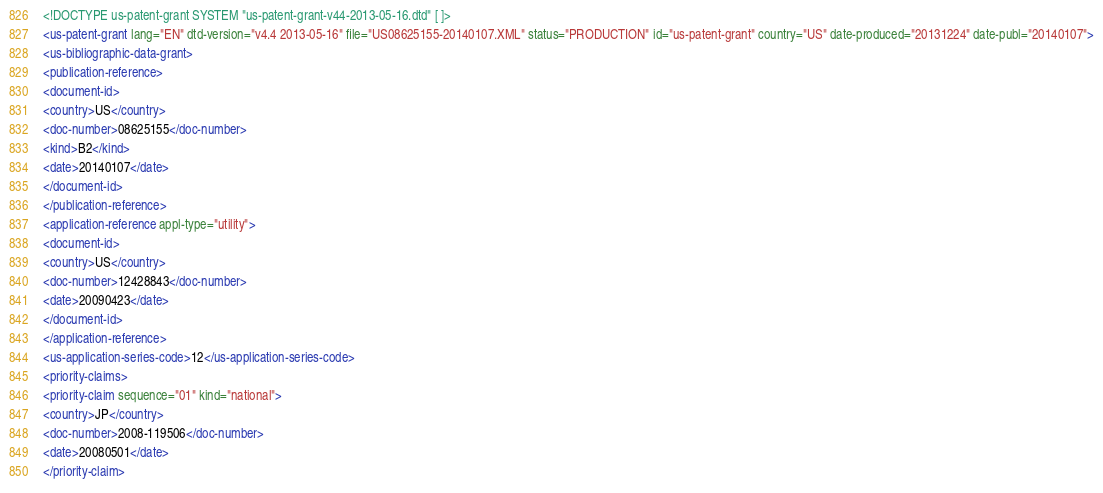<code> <loc_0><loc_0><loc_500><loc_500><_XML_><!DOCTYPE us-patent-grant SYSTEM "us-patent-grant-v44-2013-05-16.dtd" [ ]>
<us-patent-grant lang="EN" dtd-version="v4.4 2013-05-16" file="US08625155-20140107.XML" status="PRODUCTION" id="us-patent-grant" country="US" date-produced="20131224" date-publ="20140107">
<us-bibliographic-data-grant>
<publication-reference>
<document-id>
<country>US</country>
<doc-number>08625155</doc-number>
<kind>B2</kind>
<date>20140107</date>
</document-id>
</publication-reference>
<application-reference appl-type="utility">
<document-id>
<country>US</country>
<doc-number>12428843</doc-number>
<date>20090423</date>
</document-id>
</application-reference>
<us-application-series-code>12</us-application-series-code>
<priority-claims>
<priority-claim sequence="01" kind="national">
<country>JP</country>
<doc-number>2008-119506</doc-number>
<date>20080501</date>
</priority-claim></code> 